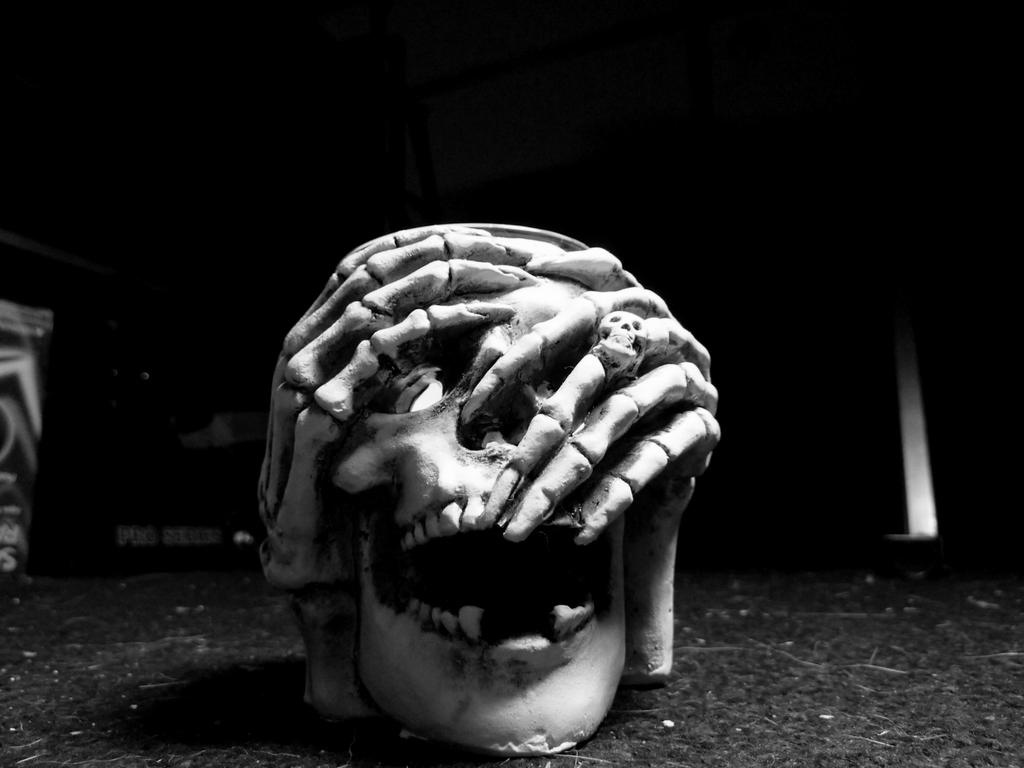What is the main subject of the image? The main subject of the image is a skull. What colors are used to depict the skull? The skull is in white and black color. What is the color of the background in the image? The background of the image is black. How many jellyfish can be seen swimming in the background of the image? There are no jellyfish present in the image; the background is black. What type of suit is the skull wearing in the image? The skull is not wearing a suit, as it is a skeletal structure without clothing. 